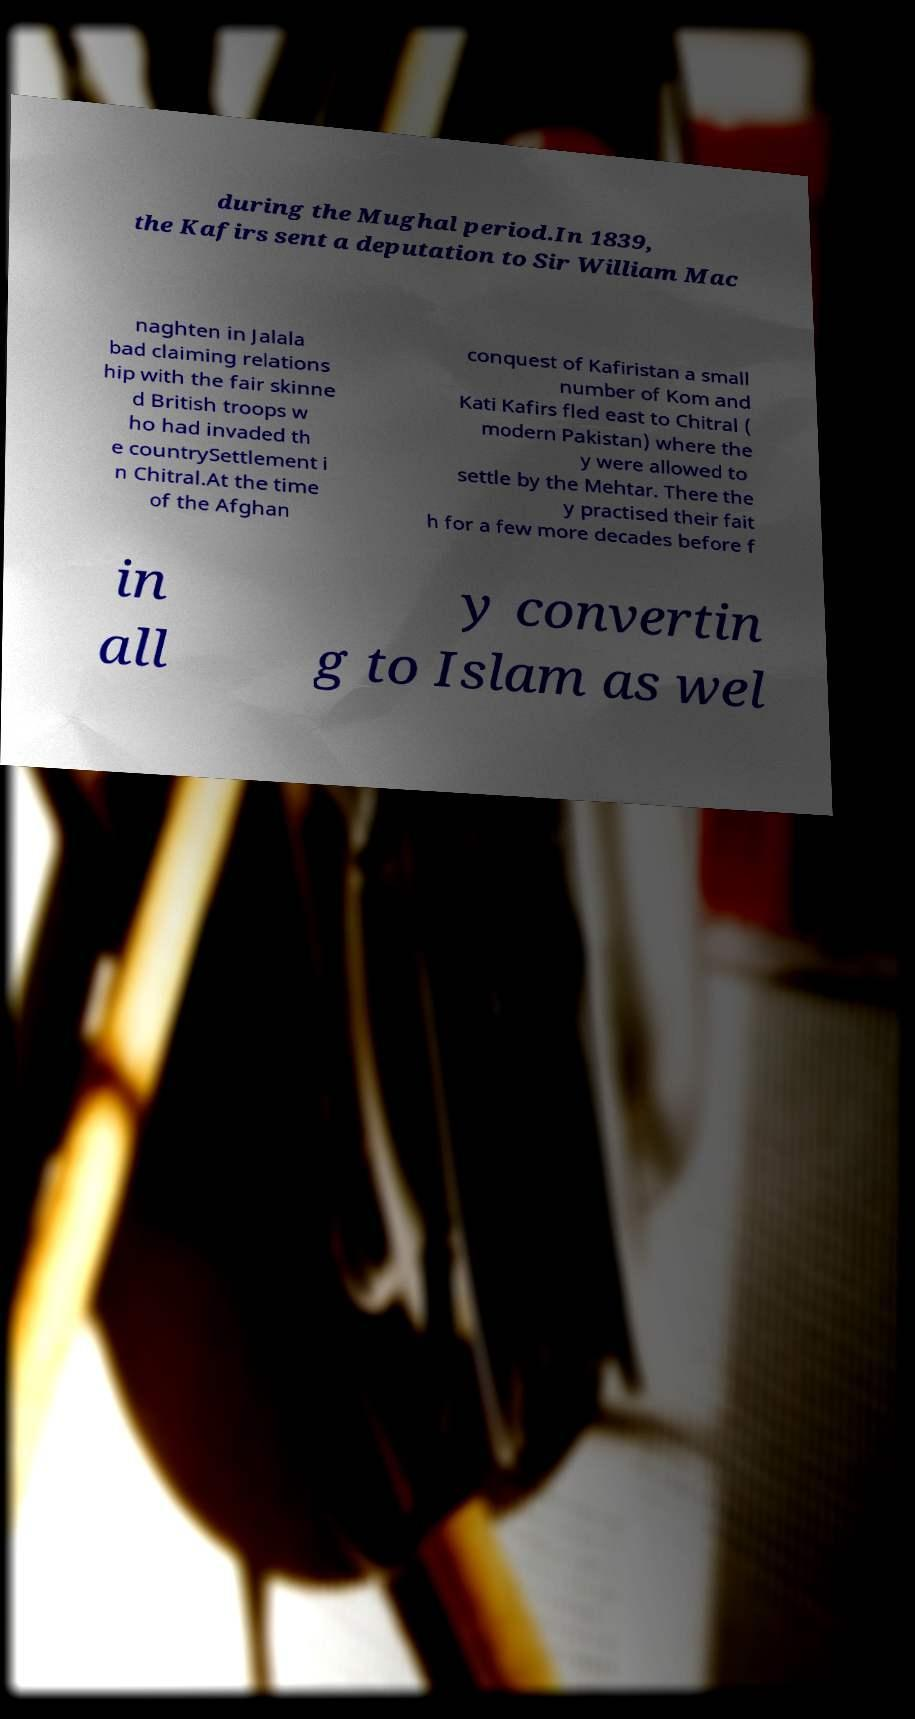Please identify and transcribe the text found in this image. during the Mughal period.In 1839, the Kafirs sent a deputation to Sir William Mac naghten in Jalala bad claiming relations hip with the fair skinne d British troops w ho had invaded th e countrySettlement i n Chitral.At the time of the Afghan conquest of Kafiristan a small number of Kom and Kati Kafirs fled east to Chitral ( modern Pakistan) where the y were allowed to settle by the Mehtar. There the y practised their fait h for a few more decades before f in all y convertin g to Islam as wel 